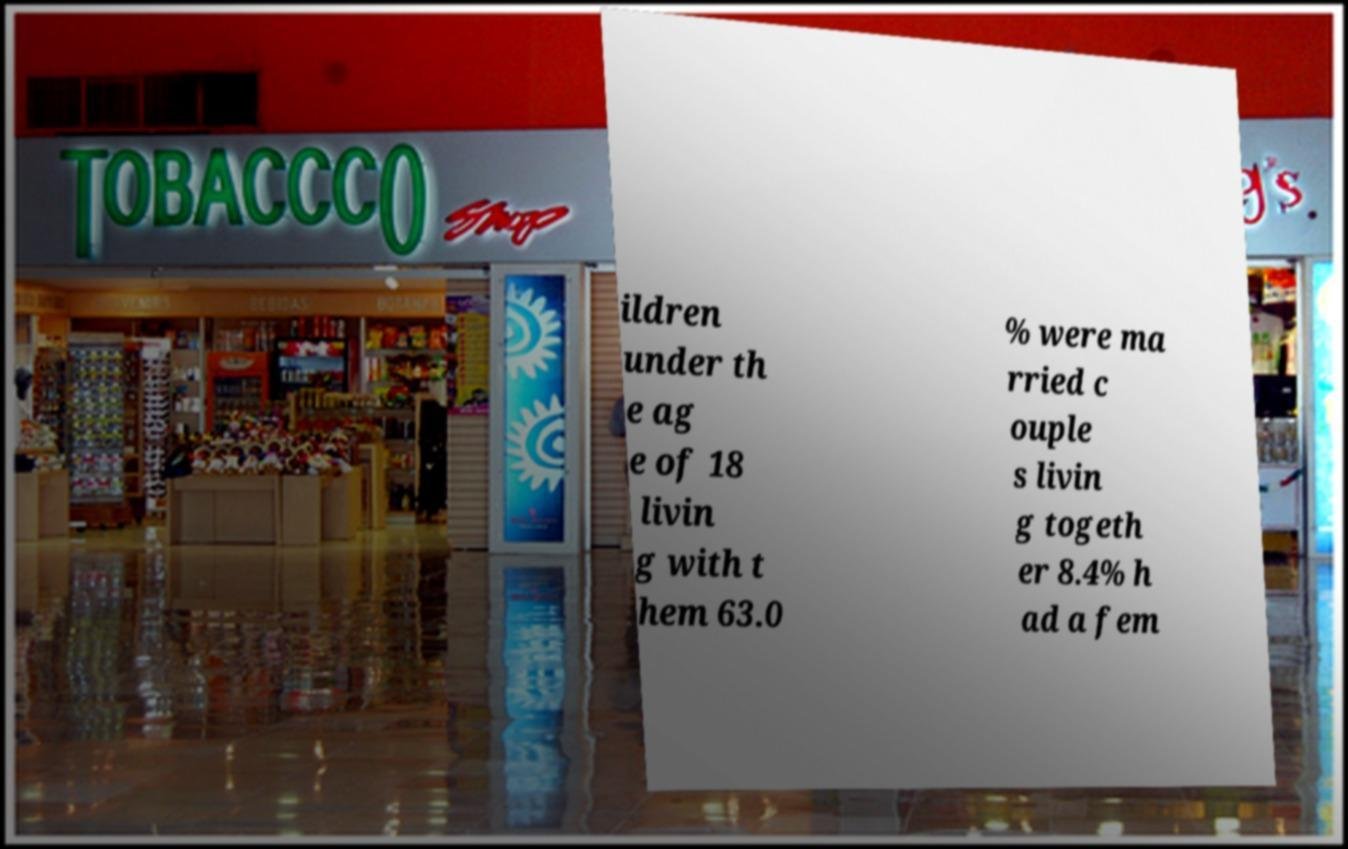What messages or text are displayed in this image? I need them in a readable, typed format. ildren under th e ag e of 18 livin g with t hem 63.0 % were ma rried c ouple s livin g togeth er 8.4% h ad a fem 